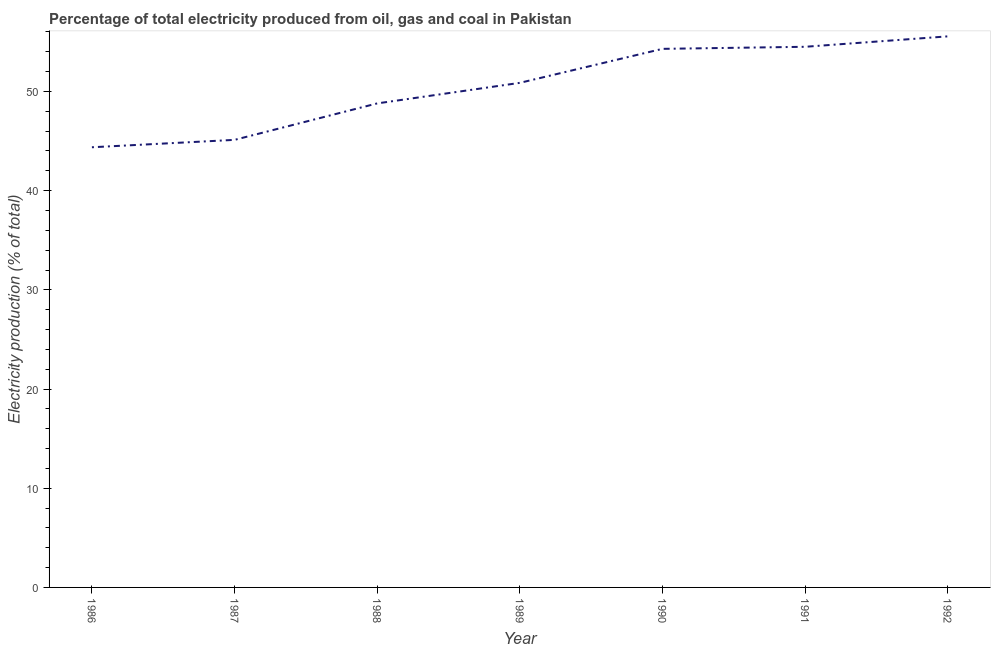What is the electricity production in 1988?
Give a very brief answer. 48.8. Across all years, what is the maximum electricity production?
Provide a succinct answer. 55.55. Across all years, what is the minimum electricity production?
Your response must be concise. 44.37. What is the sum of the electricity production?
Keep it short and to the point. 353.51. What is the difference between the electricity production in 1988 and 1992?
Provide a short and direct response. -6.76. What is the average electricity production per year?
Give a very brief answer. 50.5. What is the median electricity production?
Your answer should be very brief. 50.87. In how many years, is the electricity production greater than 34 %?
Ensure brevity in your answer.  7. Do a majority of the years between 1989 and 1992 (inclusive) have electricity production greater than 52 %?
Your response must be concise. Yes. What is the ratio of the electricity production in 1989 to that in 1991?
Keep it short and to the point. 0.93. Is the difference between the electricity production in 1989 and 1992 greater than the difference between any two years?
Give a very brief answer. No. What is the difference between the highest and the second highest electricity production?
Your answer should be very brief. 1.05. What is the difference between the highest and the lowest electricity production?
Offer a very short reply. 11.18. How many lines are there?
Your answer should be very brief. 1. How many years are there in the graph?
Give a very brief answer. 7. Are the values on the major ticks of Y-axis written in scientific E-notation?
Offer a terse response. No. Does the graph contain any zero values?
Your answer should be compact. No. Does the graph contain grids?
Keep it short and to the point. No. What is the title of the graph?
Your answer should be compact. Percentage of total electricity produced from oil, gas and coal in Pakistan. What is the label or title of the Y-axis?
Your response must be concise. Electricity production (% of total). What is the Electricity production (% of total) in 1986?
Your answer should be very brief. 44.37. What is the Electricity production (% of total) in 1987?
Offer a terse response. 45.12. What is the Electricity production (% of total) in 1988?
Give a very brief answer. 48.8. What is the Electricity production (% of total) of 1989?
Provide a short and direct response. 50.87. What is the Electricity production (% of total) of 1990?
Provide a succinct answer. 54.3. What is the Electricity production (% of total) of 1991?
Make the answer very short. 54.5. What is the Electricity production (% of total) of 1992?
Offer a very short reply. 55.55. What is the difference between the Electricity production (% of total) in 1986 and 1987?
Your response must be concise. -0.75. What is the difference between the Electricity production (% of total) in 1986 and 1988?
Ensure brevity in your answer.  -4.42. What is the difference between the Electricity production (% of total) in 1986 and 1989?
Offer a very short reply. -6.49. What is the difference between the Electricity production (% of total) in 1986 and 1990?
Give a very brief answer. -9.92. What is the difference between the Electricity production (% of total) in 1986 and 1991?
Your answer should be very brief. -10.13. What is the difference between the Electricity production (% of total) in 1986 and 1992?
Your response must be concise. -11.18. What is the difference between the Electricity production (% of total) in 1987 and 1988?
Provide a short and direct response. -3.68. What is the difference between the Electricity production (% of total) in 1987 and 1989?
Your answer should be very brief. -5.75. What is the difference between the Electricity production (% of total) in 1987 and 1990?
Offer a very short reply. -9.18. What is the difference between the Electricity production (% of total) in 1987 and 1991?
Your response must be concise. -9.38. What is the difference between the Electricity production (% of total) in 1987 and 1992?
Your response must be concise. -10.43. What is the difference between the Electricity production (% of total) in 1988 and 1989?
Make the answer very short. -2.07. What is the difference between the Electricity production (% of total) in 1988 and 1990?
Your response must be concise. -5.5. What is the difference between the Electricity production (% of total) in 1988 and 1991?
Keep it short and to the point. -5.71. What is the difference between the Electricity production (% of total) in 1988 and 1992?
Provide a succinct answer. -6.76. What is the difference between the Electricity production (% of total) in 1989 and 1990?
Your answer should be very brief. -3.43. What is the difference between the Electricity production (% of total) in 1989 and 1991?
Offer a very short reply. -3.64. What is the difference between the Electricity production (% of total) in 1989 and 1992?
Your answer should be compact. -4.69. What is the difference between the Electricity production (% of total) in 1990 and 1991?
Your answer should be compact. -0.21. What is the difference between the Electricity production (% of total) in 1990 and 1992?
Your response must be concise. -1.26. What is the difference between the Electricity production (% of total) in 1991 and 1992?
Provide a succinct answer. -1.05. What is the ratio of the Electricity production (% of total) in 1986 to that in 1988?
Ensure brevity in your answer.  0.91. What is the ratio of the Electricity production (% of total) in 1986 to that in 1989?
Give a very brief answer. 0.87. What is the ratio of the Electricity production (% of total) in 1986 to that in 1990?
Your answer should be very brief. 0.82. What is the ratio of the Electricity production (% of total) in 1986 to that in 1991?
Provide a succinct answer. 0.81. What is the ratio of the Electricity production (% of total) in 1986 to that in 1992?
Offer a very short reply. 0.8. What is the ratio of the Electricity production (% of total) in 1987 to that in 1988?
Keep it short and to the point. 0.93. What is the ratio of the Electricity production (% of total) in 1987 to that in 1989?
Offer a terse response. 0.89. What is the ratio of the Electricity production (% of total) in 1987 to that in 1990?
Ensure brevity in your answer.  0.83. What is the ratio of the Electricity production (% of total) in 1987 to that in 1991?
Your answer should be very brief. 0.83. What is the ratio of the Electricity production (% of total) in 1987 to that in 1992?
Provide a succinct answer. 0.81. What is the ratio of the Electricity production (% of total) in 1988 to that in 1989?
Give a very brief answer. 0.96. What is the ratio of the Electricity production (% of total) in 1988 to that in 1990?
Your answer should be very brief. 0.9. What is the ratio of the Electricity production (% of total) in 1988 to that in 1991?
Provide a short and direct response. 0.9. What is the ratio of the Electricity production (% of total) in 1988 to that in 1992?
Provide a short and direct response. 0.88. What is the ratio of the Electricity production (% of total) in 1989 to that in 1990?
Make the answer very short. 0.94. What is the ratio of the Electricity production (% of total) in 1989 to that in 1991?
Your answer should be compact. 0.93. What is the ratio of the Electricity production (% of total) in 1989 to that in 1992?
Make the answer very short. 0.92. What is the ratio of the Electricity production (% of total) in 1990 to that in 1991?
Ensure brevity in your answer.  1. 